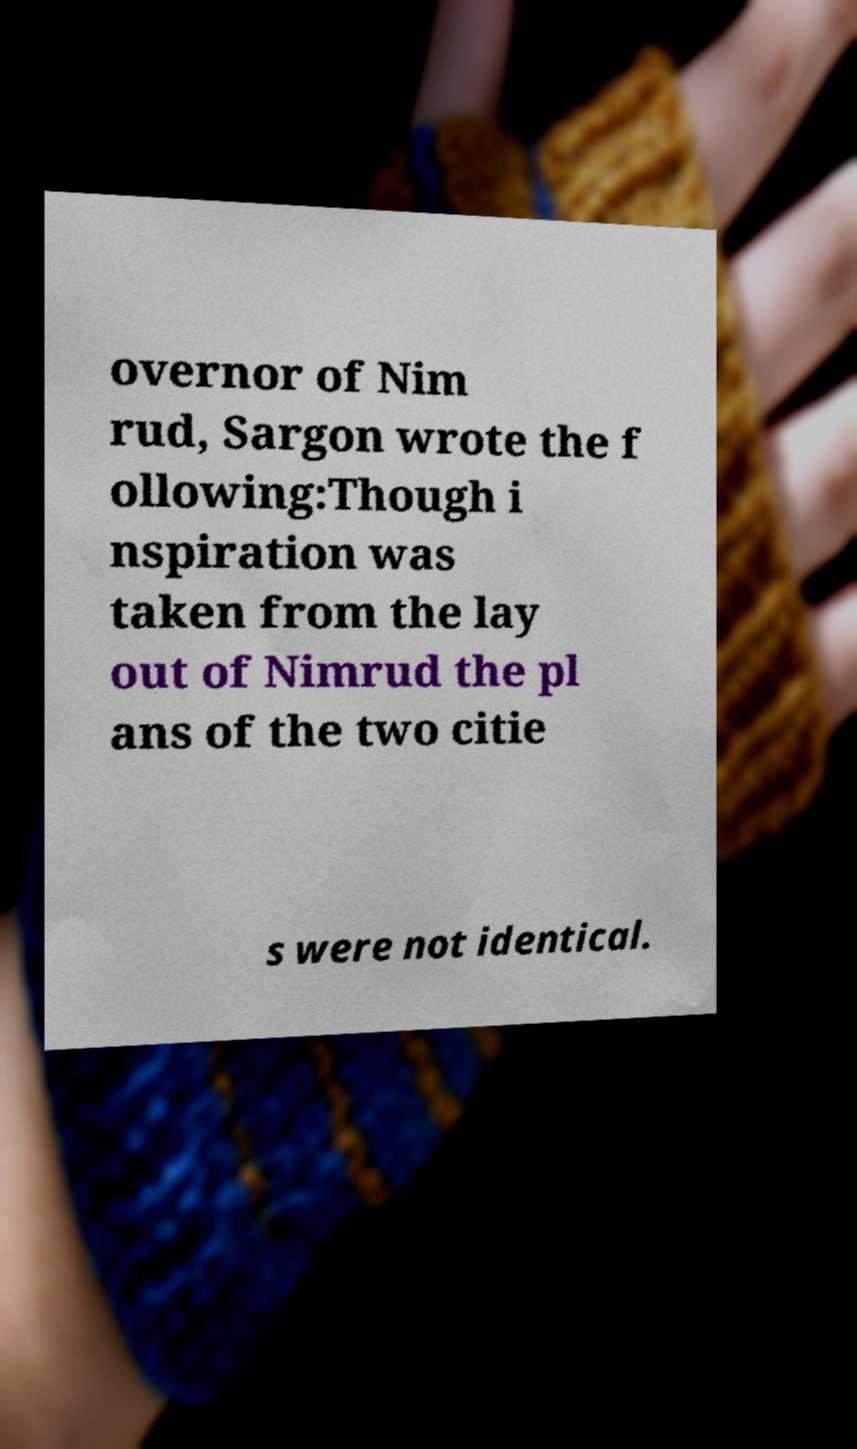For documentation purposes, I need the text within this image transcribed. Could you provide that? overnor of Nim rud, Sargon wrote the f ollowing:Though i nspiration was taken from the lay out of Nimrud the pl ans of the two citie s were not identical. 